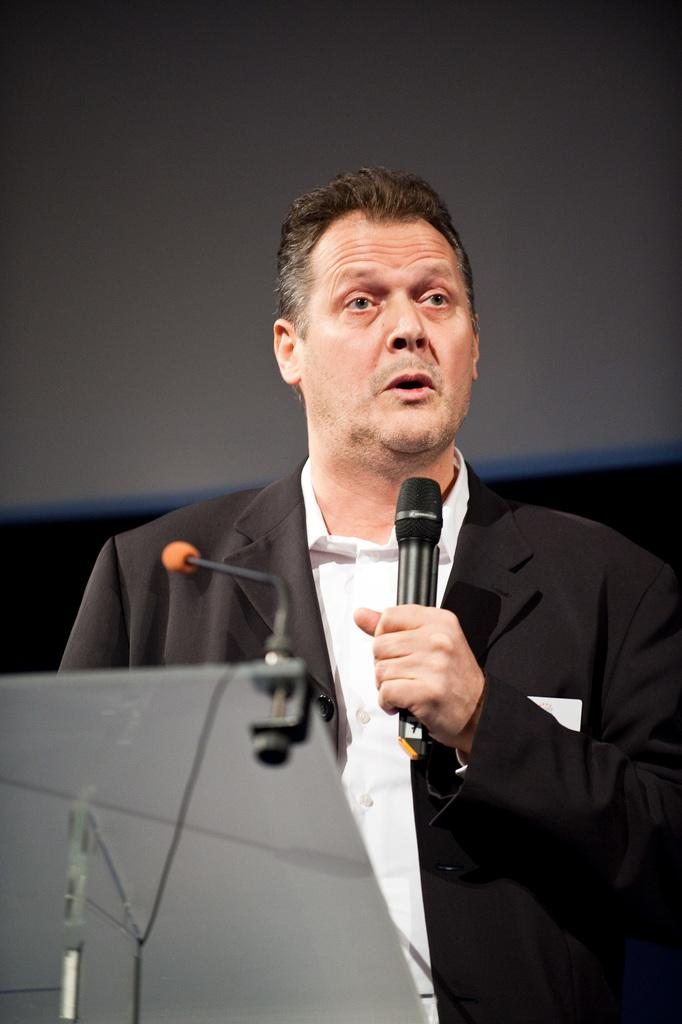Who is the main subject in the image? There is a man in the image. What is the man wearing? The man is wearing a black jacket. What is the man doing in the image? The man is talking on a microphone. What type of pet can be seen in the image? There is no pet visible in the image. 